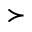<formula> <loc_0><loc_0><loc_500><loc_500>\succ</formula> 